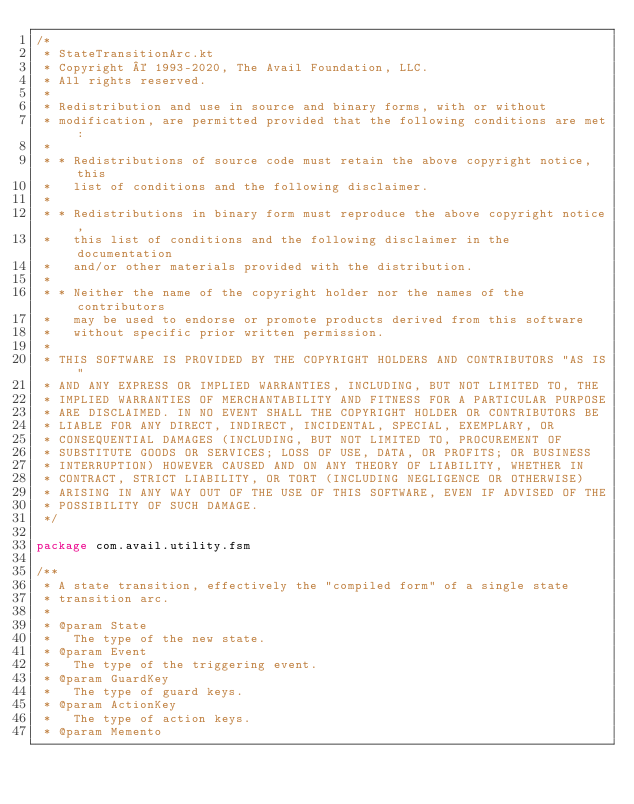<code> <loc_0><loc_0><loc_500><loc_500><_Kotlin_>/*
 * StateTransitionArc.kt
 * Copyright © 1993-2020, The Avail Foundation, LLC.
 * All rights reserved.
 *
 * Redistribution and use in source and binary forms, with or without
 * modification, are permitted provided that the following conditions are met:
 *
 * * Redistributions of source code must retain the above copyright notice, this
 *   list of conditions and the following disclaimer.
 *
 * * Redistributions in binary form must reproduce the above copyright notice,
 *   this list of conditions and the following disclaimer in the documentation
 *   and/or other materials provided with the distribution.
 *
 * * Neither the name of the copyright holder nor the names of the contributors
 *   may be used to endorse or promote products derived from this software
 *   without specific prior written permission.
 *
 * THIS SOFTWARE IS PROVIDED BY THE COPYRIGHT HOLDERS AND CONTRIBUTORS "AS IS"
 * AND ANY EXPRESS OR IMPLIED WARRANTIES, INCLUDING, BUT NOT LIMITED TO, THE
 * IMPLIED WARRANTIES OF MERCHANTABILITY AND FITNESS FOR A PARTICULAR PURPOSE
 * ARE DISCLAIMED. IN NO EVENT SHALL THE COPYRIGHT HOLDER OR CONTRIBUTORS BE
 * LIABLE FOR ANY DIRECT, INDIRECT, INCIDENTAL, SPECIAL, EXEMPLARY, OR
 * CONSEQUENTIAL DAMAGES (INCLUDING, BUT NOT LIMITED TO, PROCUREMENT OF
 * SUBSTITUTE GOODS OR SERVICES; LOSS OF USE, DATA, OR PROFITS; OR BUSINESS
 * INTERRUPTION) HOWEVER CAUSED AND ON ANY THEORY OF LIABILITY, WHETHER IN
 * CONTRACT, STRICT LIABILITY, OR TORT (INCLUDING NEGLIGENCE OR OTHERWISE)
 * ARISING IN ANY WAY OUT OF THE USE OF THIS SOFTWARE, EVEN IF ADVISED OF THE
 * POSSIBILITY OF SUCH DAMAGE.
 */

package com.avail.utility.fsm

/**
 * A state transition, effectively the "compiled form" of a single state
 * transition arc.
 *
 * @param State
 *   The type of the new state.
 * @param Event
 *   The type of the triggering event.
 * @param GuardKey
 *   The type of guard keys.
 * @param ActionKey
 *   The type of action keys.
 * @param Memento</code> 